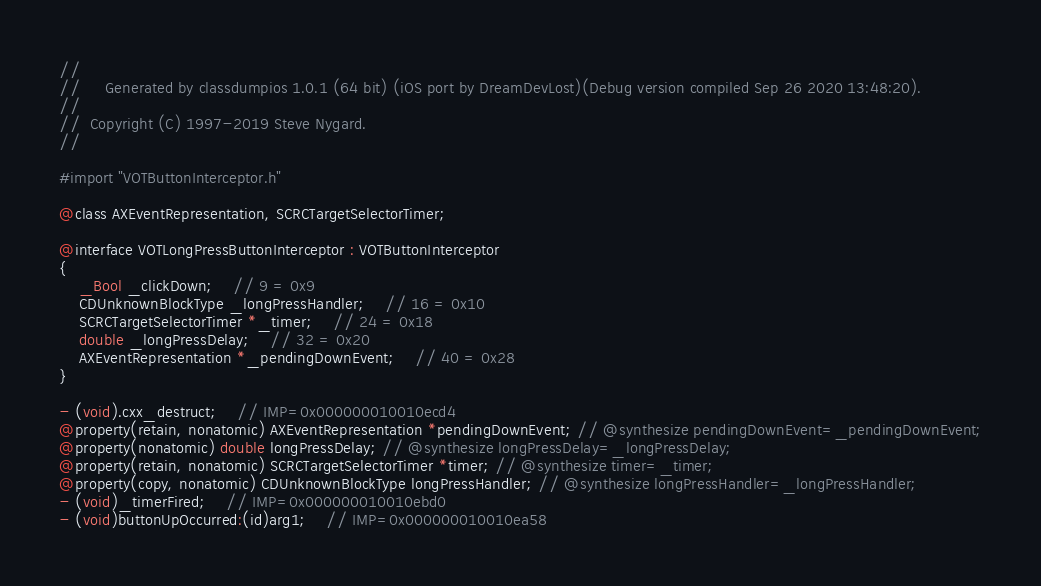<code> <loc_0><loc_0><loc_500><loc_500><_C_>//
//     Generated by classdumpios 1.0.1 (64 bit) (iOS port by DreamDevLost)(Debug version compiled Sep 26 2020 13:48:20).
//
//  Copyright (C) 1997-2019 Steve Nygard.
//

#import "VOTButtonInterceptor.h"

@class AXEventRepresentation, SCRCTargetSelectorTimer;

@interface VOTLongPressButtonInterceptor : VOTButtonInterceptor
{
    _Bool _clickDown;	// 9 = 0x9
    CDUnknownBlockType _longPressHandler;	// 16 = 0x10
    SCRCTargetSelectorTimer *_timer;	// 24 = 0x18
    double _longPressDelay;	// 32 = 0x20
    AXEventRepresentation *_pendingDownEvent;	// 40 = 0x28
}

- (void).cxx_destruct;	// IMP=0x000000010010ecd4
@property(retain, nonatomic) AXEventRepresentation *pendingDownEvent; // @synthesize pendingDownEvent=_pendingDownEvent;
@property(nonatomic) double longPressDelay; // @synthesize longPressDelay=_longPressDelay;
@property(retain, nonatomic) SCRCTargetSelectorTimer *timer; // @synthesize timer=_timer;
@property(copy, nonatomic) CDUnknownBlockType longPressHandler; // @synthesize longPressHandler=_longPressHandler;
- (void)_timerFired;	// IMP=0x000000010010ebd0
- (void)buttonUpOccurred:(id)arg1;	// IMP=0x000000010010ea58</code> 